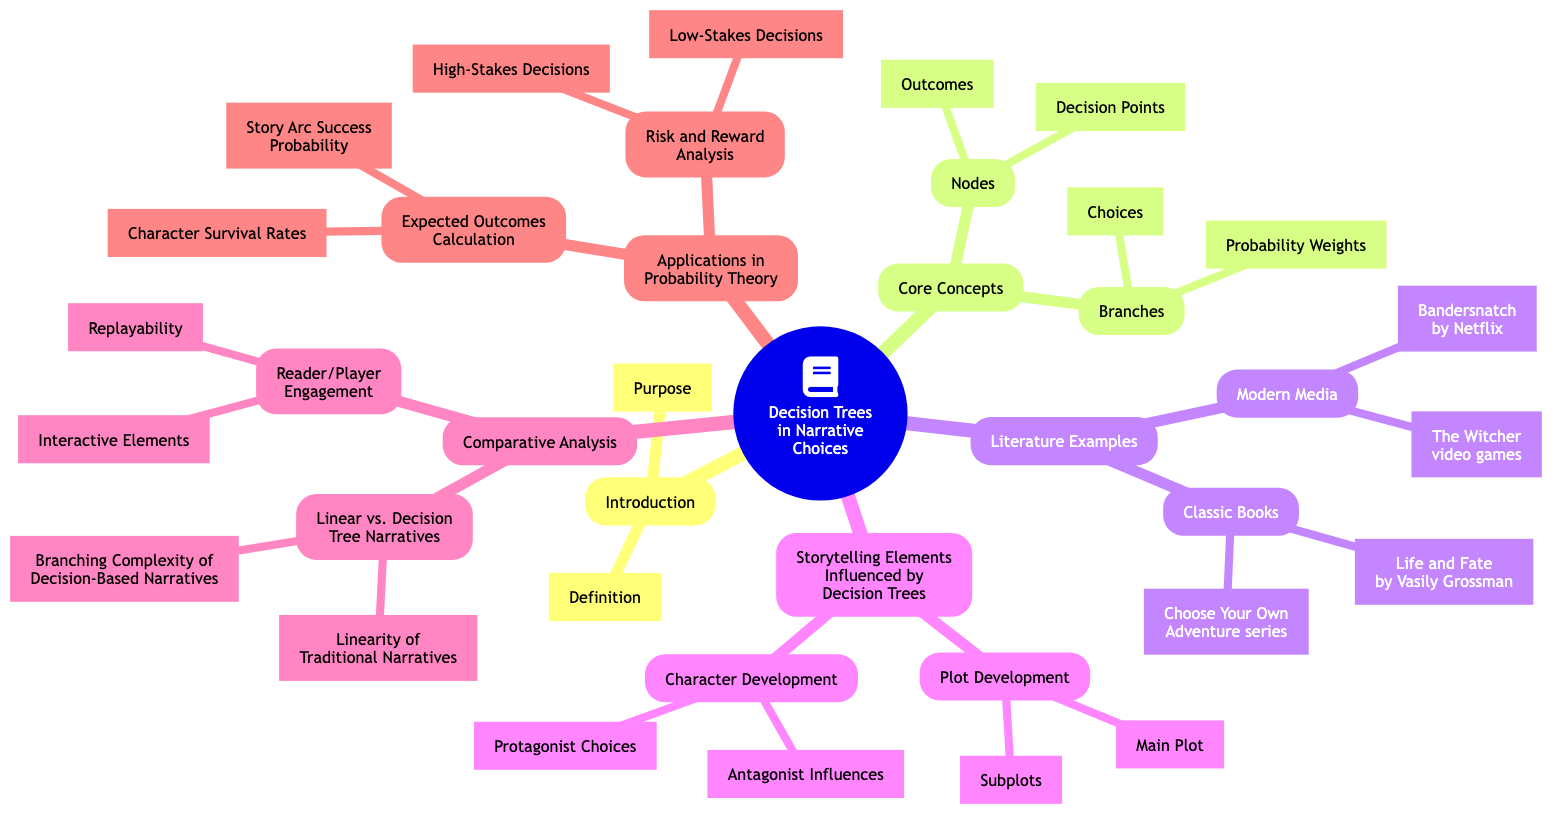What are the two main components of Nodes in Decision Trees? The diagram states that the two components of Nodes are "Decision Points" and "Outcomes," which can be found under the Core Concepts section.
Answer: Decision Points, Outcomes How many types of literature examples are listed? The diagram indicates that there are two main categories of literature examples: "Classic Books" and "Modern Media." Therefore, the total is two.
Answer: 2 What is one example of a Classic Book listed? Under the Literature Examples section, the Classic Books category includes "Choose Your Own Adventure series," which directly answers the question.
Answer: Choose Your Own Adventure series What do the Branches represent in Decision Trees? According to the Core Concepts section, Branches represent "Choices" and "Probability Weights." This conveys the role of Branches in representing the flows from one decision to outcomes based on selected choices.
Answer: Choices, Probability Weights Which storytelling element in the mind map is influenced by Protagonist Choices? The diagram shows that Protagonist Choices influence "Character Development" under the Storytelling Elements section, where Character Development is a specific node related to storytelling influenced by decision-making.
Answer: Character Development How do Decision Trees affect Reader Engagement? The diagram highlights that Reader/Player Engagement includes "Interactive Elements" and "Replayability," indicating how decision trees can enhance the involvement and excitement of readers or players.
Answer: Interactive Elements, Replayability What is a risk analyzed in Decision Trees according to the diagram? Within the Applications in Probability Theory section, "High-Stakes Decisions" is noted as a type of risk analyzed in Decision Trees, signifying their application in evaluating potential outcomes in critical scenarios.
Answer: High-Stakes Decisions What contrasts with Decision Tree Narratives according to the diagram? The diagram presents a comparative analysis, where "Linearity of Traditional Narratives" is listed as a contrasting characteristic compared to Decision Tree Narratives, emphasizing the difference between straightforward and branching structures in storytelling.
Answer: Linearity of Traditional Narratives What expected outcome is calculated regarding character survival? The diagram lists "Character Survival Rates" under the Expected Outcomes Calculation section within Applications in Probability Theory, indicating it is a specific expected outcome that can be derived through decision trees.
Answer: Character Survival Rates 